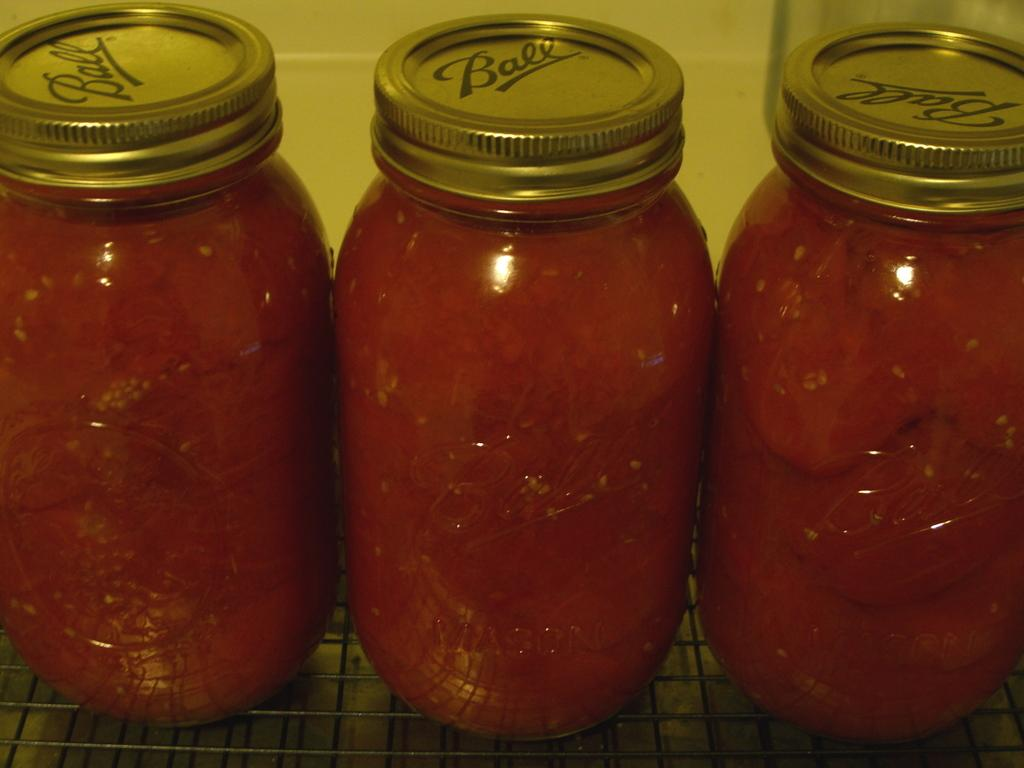How many bottles are visible in the image? There are three bottles in the image. What are the bottles filled with? The bottles are filled with sauces. What type of holiday is being celebrated in the image? There is no indication of a holiday being celebrated in the image, as it only features three bottles filled with sauces. 